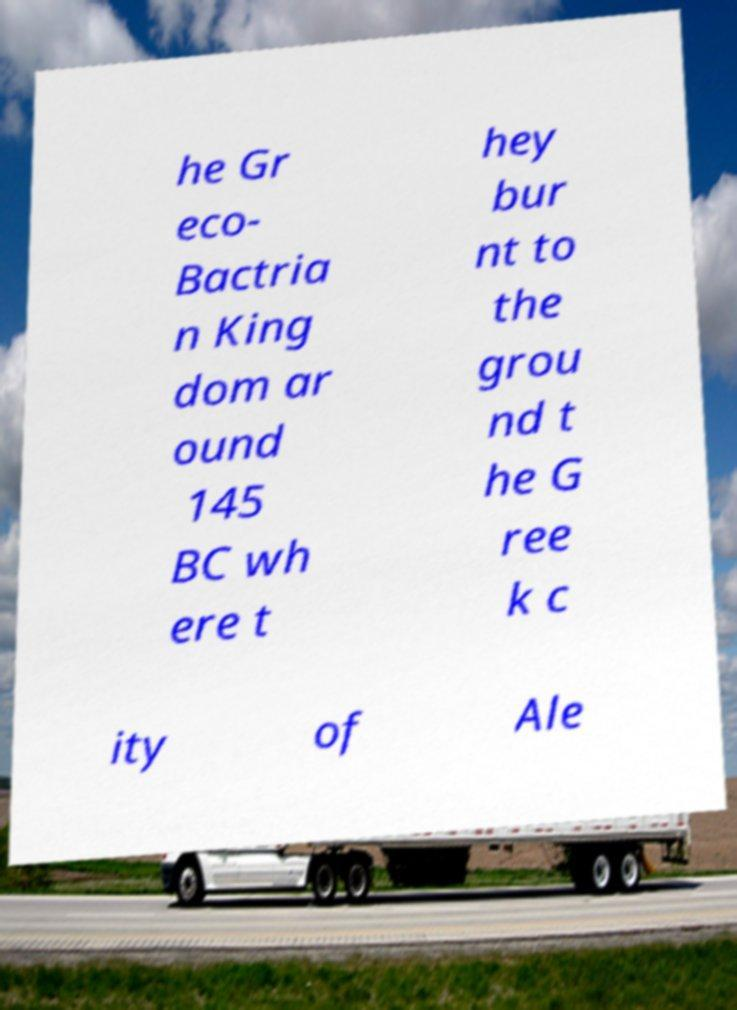Can you accurately transcribe the text from the provided image for me? he Gr eco- Bactria n King dom ar ound 145 BC wh ere t hey bur nt to the grou nd t he G ree k c ity of Ale 